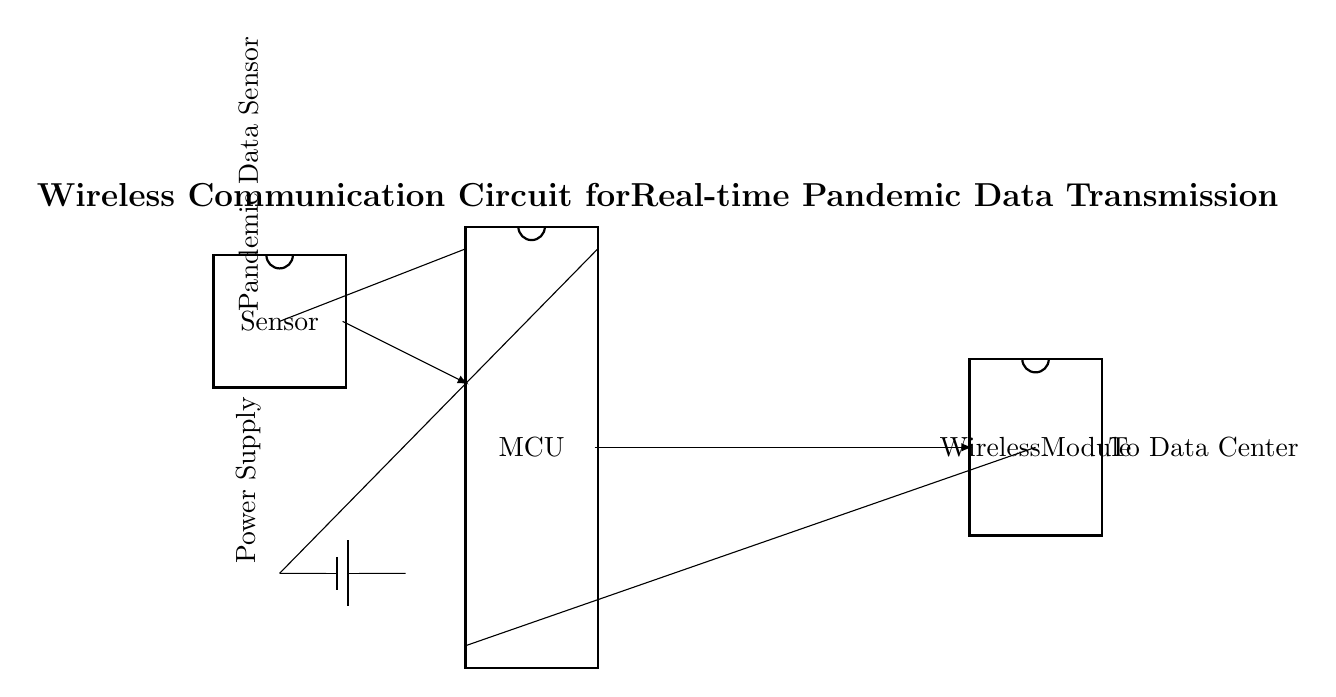What is the role of the MCU? The MCU (Microcontroller Unit) acts as the central processing unit, managing data from the sensor and controlling the wireless communication module.
Answer: Central processing unit What is connected to pin 10 of the MCU? Pin 10 of the MCU is connected to the wireless module, which facilitates the data transmission to the data center.
Answer: Wireless module How many pins does the wireless module have? The wireless module has eight pins as indicated in the diagram.
Answer: Eight pins What does the sensor measure? The sensor measures pandemic data, as labeled in the diagram near the sensor component.
Answer: Pandemic data What is the power source of this circuit? The power source of the circuit is a battery, which is indicated at the bottom of the diagram.
Answer: Battery Why does data flow from the sensor to the MCU? Data flows from the sensor to the MCU because the MCU needs to process the sensor data for transmission. The arrow indicates the direction of data flow, primarily for processing purposes before transmission.
Answer: Processing What indicates the direction of data flow in the circuit? The arrows labeled with 'latex' indicate the direction of the data flow, indicating where the data is being sent from and to.
Answer: Arrows 